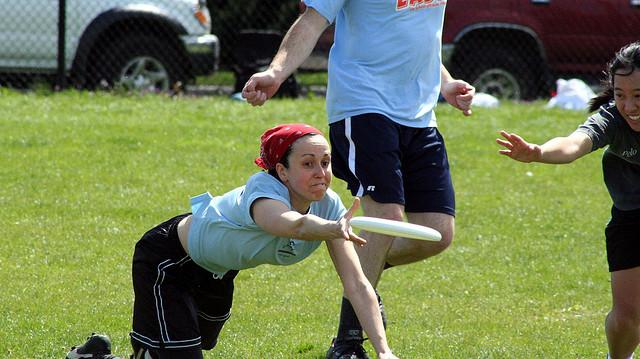What is the woman ready to do? catch frisbee 